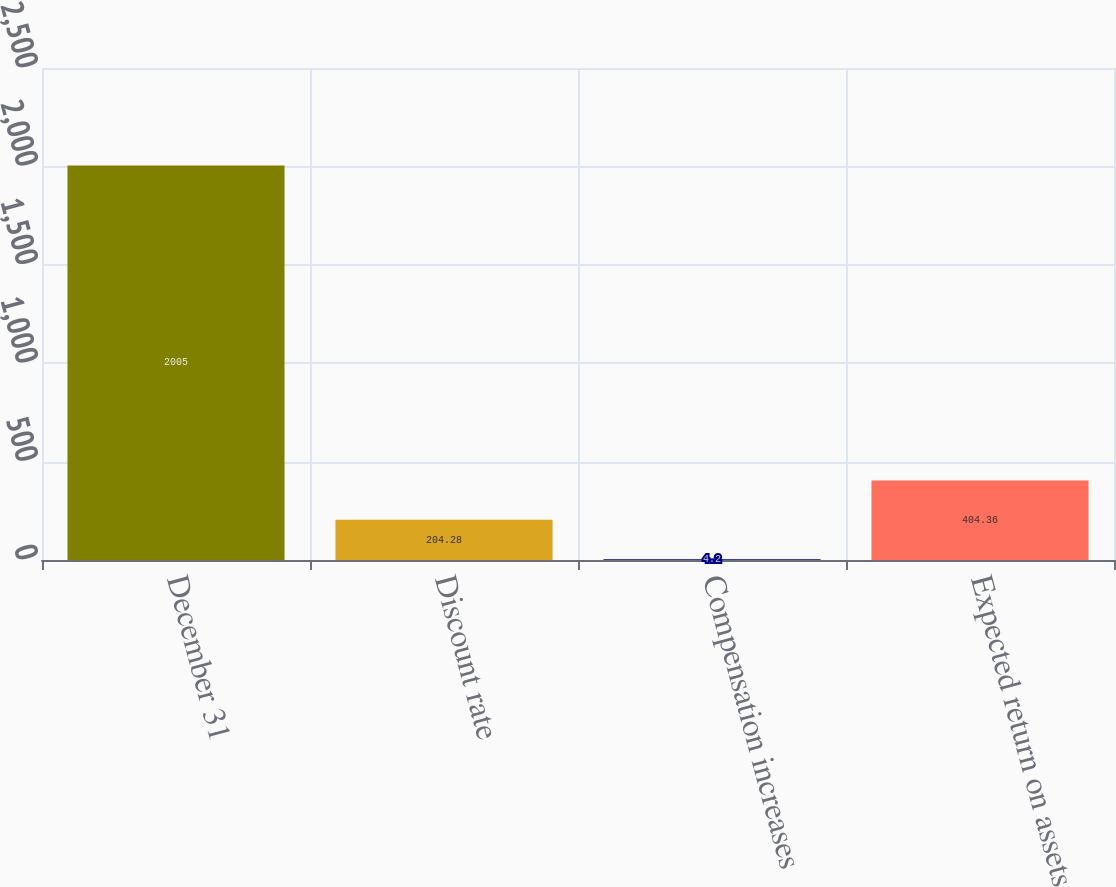Convert chart to OTSL. <chart><loc_0><loc_0><loc_500><loc_500><bar_chart><fcel>December 31<fcel>Discount rate<fcel>Compensation increases<fcel>Expected return on assets<nl><fcel>2005<fcel>204.28<fcel>4.2<fcel>404.36<nl></chart> 